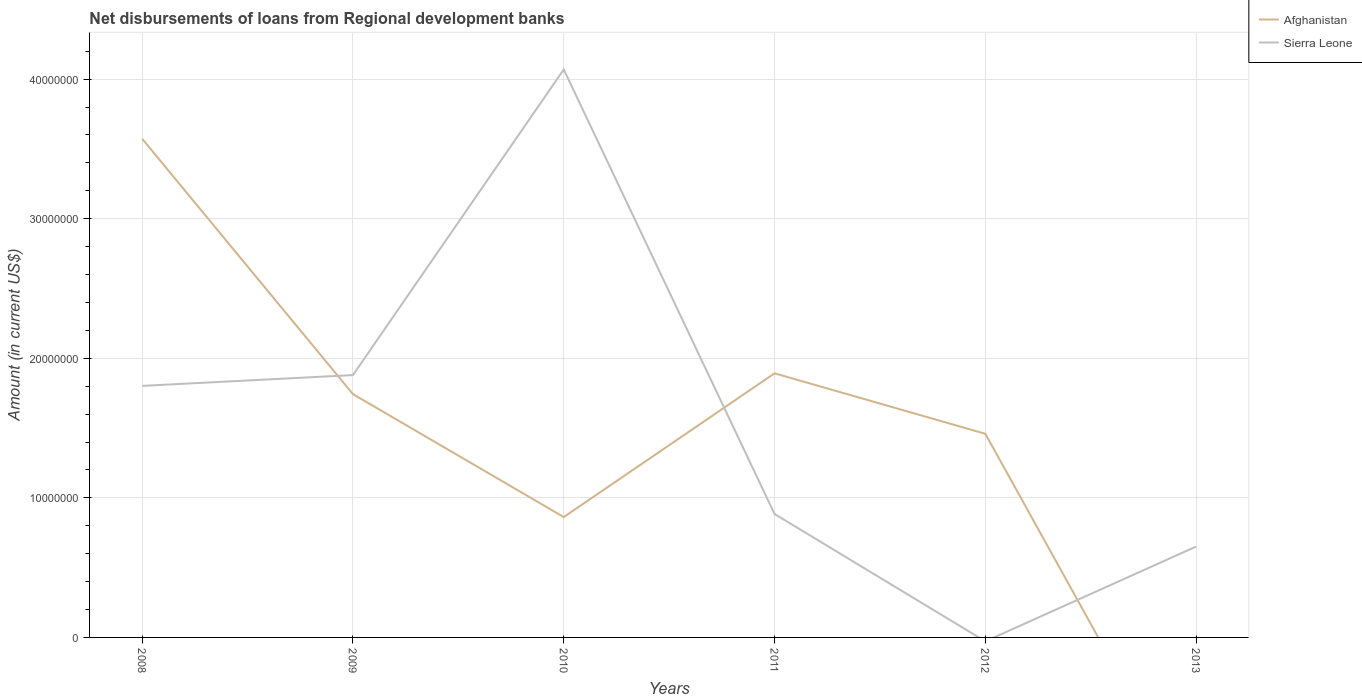Across all years, what is the maximum amount of disbursements of loans from regional development banks in Afghanistan?
Make the answer very short. 0. What is the total amount of disbursements of loans from regional development banks in Afghanistan in the graph?
Make the answer very short. -5.97e+06. What is the difference between the highest and the second highest amount of disbursements of loans from regional development banks in Afghanistan?
Offer a very short reply. 3.57e+07. What is the difference between the highest and the lowest amount of disbursements of loans from regional development banks in Afghanistan?
Give a very brief answer. 3. How many lines are there?
Keep it short and to the point. 2. Does the graph contain any zero values?
Your response must be concise. Yes. How are the legend labels stacked?
Provide a short and direct response. Vertical. What is the title of the graph?
Provide a succinct answer. Net disbursements of loans from Regional development banks. Does "Maldives" appear as one of the legend labels in the graph?
Provide a succinct answer. No. What is the Amount (in current US$) of Afghanistan in 2008?
Offer a terse response. 3.57e+07. What is the Amount (in current US$) in Sierra Leone in 2008?
Provide a short and direct response. 1.80e+07. What is the Amount (in current US$) in Afghanistan in 2009?
Offer a very short reply. 1.74e+07. What is the Amount (in current US$) in Sierra Leone in 2009?
Provide a succinct answer. 1.88e+07. What is the Amount (in current US$) of Afghanistan in 2010?
Ensure brevity in your answer.  8.62e+06. What is the Amount (in current US$) of Sierra Leone in 2010?
Keep it short and to the point. 4.07e+07. What is the Amount (in current US$) in Afghanistan in 2011?
Your answer should be very brief. 1.89e+07. What is the Amount (in current US$) of Sierra Leone in 2011?
Provide a short and direct response. 8.84e+06. What is the Amount (in current US$) of Afghanistan in 2012?
Ensure brevity in your answer.  1.46e+07. What is the Amount (in current US$) of Afghanistan in 2013?
Your answer should be very brief. 0. What is the Amount (in current US$) in Sierra Leone in 2013?
Your answer should be compact. 6.51e+06. Across all years, what is the maximum Amount (in current US$) in Afghanistan?
Offer a very short reply. 3.57e+07. Across all years, what is the maximum Amount (in current US$) in Sierra Leone?
Offer a very short reply. 4.07e+07. Across all years, what is the minimum Amount (in current US$) in Afghanistan?
Ensure brevity in your answer.  0. Across all years, what is the minimum Amount (in current US$) in Sierra Leone?
Provide a short and direct response. 0. What is the total Amount (in current US$) of Afghanistan in the graph?
Give a very brief answer. 9.53e+07. What is the total Amount (in current US$) in Sierra Leone in the graph?
Your response must be concise. 9.29e+07. What is the difference between the Amount (in current US$) in Afghanistan in 2008 and that in 2009?
Make the answer very short. 1.83e+07. What is the difference between the Amount (in current US$) of Sierra Leone in 2008 and that in 2009?
Provide a succinct answer. -7.74e+05. What is the difference between the Amount (in current US$) of Afghanistan in 2008 and that in 2010?
Provide a succinct answer. 2.71e+07. What is the difference between the Amount (in current US$) of Sierra Leone in 2008 and that in 2010?
Your response must be concise. -2.27e+07. What is the difference between the Amount (in current US$) of Afghanistan in 2008 and that in 2011?
Give a very brief answer. 1.68e+07. What is the difference between the Amount (in current US$) in Sierra Leone in 2008 and that in 2011?
Offer a very short reply. 9.18e+06. What is the difference between the Amount (in current US$) of Afghanistan in 2008 and that in 2012?
Your response must be concise. 2.11e+07. What is the difference between the Amount (in current US$) in Sierra Leone in 2008 and that in 2013?
Ensure brevity in your answer.  1.15e+07. What is the difference between the Amount (in current US$) of Afghanistan in 2009 and that in 2010?
Make the answer very short. 8.81e+06. What is the difference between the Amount (in current US$) of Sierra Leone in 2009 and that in 2010?
Ensure brevity in your answer.  -2.19e+07. What is the difference between the Amount (in current US$) of Afghanistan in 2009 and that in 2011?
Your answer should be compact. -1.49e+06. What is the difference between the Amount (in current US$) of Sierra Leone in 2009 and that in 2011?
Keep it short and to the point. 9.95e+06. What is the difference between the Amount (in current US$) in Afghanistan in 2009 and that in 2012?
Provide a succinct answer. 2.84e+06. What is the difference between the Amount (in current US$) of Sierra Leone in 2009 and that in 2013?
Give a very brief answer. 1.23e+07. What is the difference between the Amount (in current US$) of Afghanistan in 2010 and that in 2011?
Your answer should be compact. -1.03e+07. What is the difference between the Amount (in current US$) of Sierra Leone in 2010 and that in 2011?
Ensure brevity in your answer.  3.18e+07. What is the difference between the Amount (in current US$) in Afghanistan in 2010 and that in 2012?
Give a very brief answer. -5.97e+06. What is the difference between the Amount (in current US$) of Sierra Leone in 2010 and that in 2013?
Provide a short and direct response. 3.42e+07. What is the difference between the Amount (in current US$) of Afghanistan in 2011 and that in 2012?
Give a very brief answer. 4.33e+06. What is the difference between the Amount (in current US$) of Sierra Leone in 2011 and that in 2013?
Offer a terse response. 2.33e+06. What is the difference between the Amount (in current US$) of Afghanistan in 2008 and the Amount (in current US$) of Sierra Leone in 2009?
Provide a short and direct response. 1.69e+07. What is the difference between the Amount (in current US$) in Afghanistan in 2008 and the Amount (in current US$) in Sierra Leone in 2010?
Provide a succinct answer. -4.96e+06. What is the difference between the Amount (in current US$) in Afghanistan in 2008 and the Amount (in current US$) in Sierra Leone in 2011?
Give a very brief answer. 2.69e+07. What is the difference between the Amount (in current US$) in Afghanistan in 2008 and the Amount (in current US$) in Sierra Leone in 2013?
Give a very brief answer. 2.92e+07. What is the difference between the Amount (in current US$) in Afghanistan in 2009 and the Amount (in current US$) in Sierra Leone in 2010?
Keep it short and to the point. -2.33e+07. What is the difference between the Amount (in current US$) of Afghanistan in 2009 and the Amount (in current US$) of Sierra Leone in 2011?
Your response must be concise. 8.59e+06. What is the difference between the Amount (in current US$) in Afghanistan in 2009 and the Amount (in current US$) in Sierra Leone in 2013?
Provide a succinct answer. 1.09e+07. What is the difference between the Amount (in current US$) in Afghanistan in 2010 and the Amount (in current US$) in Sierra Leone in 2011?
Offer a terse response. -2.21e+05. What is the difference between the Amount (in current US$) of Afghanistan in 2010 and the Amount (in current US$) of Sierra Leone in 2013?
Keep it short and to the point. 2.11e+06. What is the difference between the Amount (in current US$) in Afghanistan in 2011 and the Amount (in current US$) in Sierra Leone in 2013?
Your response must be concise. 1.24e+07. What is the difference between the Amount (in current US$) of Afghanistan in 2012 and the Amount (in current US$) of Sierra Leone in 2013?
Your answer should be very brief. 8.08e+06. What is the average Amount (in current US$) in Afghanistan per year?
Your answer should be very brief. 1.59e+07. What is the average Amount (in current US$) of Sierra Leone per year?
Make the answer very short. 1.55e+07. In the year 2008, what is the difference between the Amount (in current US$) of Afghanistan and Amount (in current US$) of Sierra Leone?
Keep it short and to the point. 1.77e+07. In the year 2009, what is the difference between the Amount (in current US$) of Afghanistan and Amount (in current US$) of Sierra Leone?
Keep it short and to the point. -1.36e+06. In the year 2010, what is the difference between the Amount (in current US$) in Afghanistan and Amount (in current US$) in Sierra Leone?
Provide a succinct answer. -3.21e+07. In the year 2011, what is the difference between the Amount (in current US$) in Afghanistan and Amount (in current US$) in Sierra Leone?
Provide a succinct answer. 1.01e+07. What is the ratio of the Amount (in current US$) of Afghanistan in 2008 to that in 2009?
Provide a succinct answer. 2.05. What is the ratio of the Amount (in current US$) in Sierra Leone in 2008 to that in 2009?
Keep it short and to the point. 0.96. What is the ratio of the Amount (in current US$) of Afghanistan in 2008 to that in 2010?
Keep it short and to the point. 4.14. What is the ratio of the Amount (in current US$) of Sierra Leone in 2008 to that in 2010?
Provide a succinct answer. 0.44. What is the ratio of the Amount (in current US$) in Afghanistan in 2008 to that in 2011?
Give a very brief answer. 1.89. What is the ratio of the Amount (in current US$) in Sierra Leone in 2008 to that in 2011?
Make the answer very short. 2.04. What is the ratio of the Amount (in current US$) of Afghanistan in 2008 to that in 2012?
Your answer should be compact. 2.45. What is the ratio of the Amount (in current US$) of Sierra Leone in 2008 to that in 2013?
Provide a short and direct response. 2.77. What is the ratio of the Amount (in current US$) in Afghanistan in 2009 to that in 2010?
Your answer should be compact. 2.02. What is the ratio of the Amount (in current US$) in Sierra Leone in 2009 to that in 2010?
Your response must be concise. 0.46. What is the ratio of the Amount (in current US$) in Afghanistan in 2009 to that in 2011?
Keep it short and to the point. 0.92. What is the ratio of the Amount (in current US$) in Sierra Leone in 2009 to that in 2011?
Provide a short and direct response. 2.13. What is the ratio of the Amount (in current US$) in Afghanistan in 2009 to that in 2012?
Ensure brevity in your answer.  1.19. What is the ratio of the Amount (in current US$) of Sierra Leone in 2009 to that in 2013?
Provide a short and direct response. 2.89. What is the ratio of the Amount (in current US$) in Afghanistan in 2010 to that in 2011?
Offer a terse response. 0.46. What is the ratio of the Amount (in current US$) in Sierra Leone in 2010 to that in 2011?
Keep it short and to the point. 4.6. What is the ratio of the Amount (in current US$) of Afghanistan in 2010 to that in 2012?
Offer a terse response. 0.59. What is the ratio of the Amount (in current US$) in Sierra Leone in 2010 to that in 2013?
Your answer should be very brief. 6.25. What is the ratio of the Amount (in current US$) of Afghanistan in 2011 to that in 2012?
Keep it short and to the point. 1.3. What is the ratio of the Amount (in current US$) of Sierra Leone in 2011 to that in 2013?
Give a very brief answer. 1.36. What is the difference between the highest and the second highest Amount (in current US$) of Afghanistan?
Provide a short and direct response. 1.68e+07. What is the difference between the highest and the second highest Amount (in current US$) in Sierra Leone?
Give a very brief answer. 2.19e+07. What is the difference between the highest and the lowest Amount (in current US$) of Afghanistan?
Ensure brevity in your answer.  3.57e+07. What is the difference between the highest and the lowest Amount (in current US$) in Sierra Leone?
Ensure brevity in your answer.  4.07e+07. 